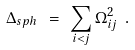Convert formula to latex. <formula><loc_0><loc_0><loc_500><loc_500>\Delta _ { s p h } \ = \ \sum _ { i < j } \Omega _ { i j } ^ { 2 } \ .</formula> 